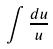<formula> <loc_0><loc_0><loc_500><loc_500>\int \frac { d u } { u }</formula> 